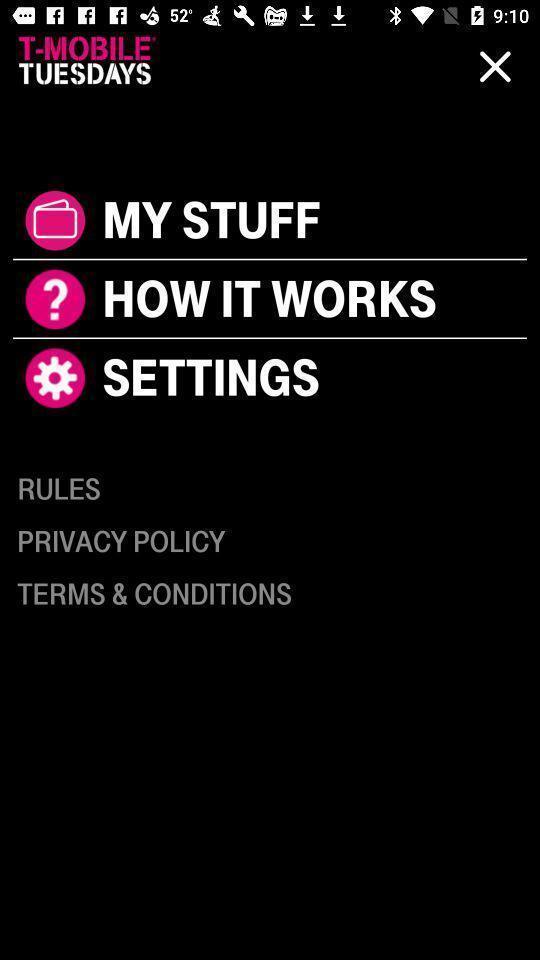Tell me about the visual elements in this screen capture. Welcome page. 